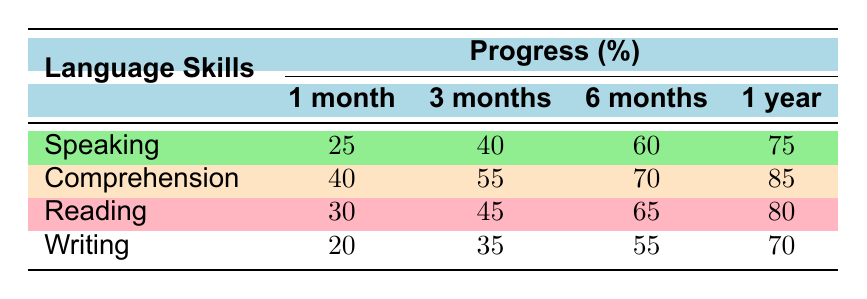What is the speaking skill percentage at 3 months post-stroke? The table shows that the progression of the speaking skill at the 3 months post-stroke mark is indicated directly under the "3 months" column for the "Speaking" row. The value is 40%.
Answer: 40% Which language skill had the highest percentage at 1 year post-stroke? The table lists the percentages for each skill at the 1 year post-stroke mark. The values are 75% for Speaking, 85% for Comprehension, 80% for Reading, and 70% for Writing. Comprehension is the highest at 85%.
Answer: Comprehension What is the average progress percentage for Reading over all time periods? To find the average for Reading, we add the percentages: \(30\% + 45\% + 65\% + 80\% = 220\%\). Then divide by 4 (number of time periods): \(220\% / 4 = 55\%\).
Answer: 55% Did the survivor achieve the milestone of writing a personal letter within the first 6 months post-stroke? The table shows the milestone of writing a personal letter was achieved at 7 months post-stroke. Since this is beyond 6 months, the answer is no.
Answer: No What is the difference in comprehension skill percentage between 1 month and 6 months post-stroke? The comprehension skill percentage at 1 month is 40% and at 6 months is 70%. The difference is calculated as \(70\% - 40\% = 30\%\).
Answer: 30% Which skill shows the least improvement from 1 month to 1 year post-stroke? To determine the least improvement, we calculate the progress for each skill from 1 month to 1 year: Speaking (75%-25% = 50%), Comprehension (85%-40% = 45%), Reading (80%-30% = 50%), and Writing (70%-20% = 50%). The lowest improvement is for Comprehension, with an improvement of 45%.
Answer: Comprehension What is the frequency of "Home Exercises with Sibling"? The "Home Exercises with Sibling" method has a listed frequency of "Daily" in the therapy methods section of the data.
Answer: Daily Calculate the total percentage improvement for speaking skill from 1 month to 1 year post-stroke. The speaking skill percentage at 1 month is 25% and at 1 year is 75%. The total improvement is \(75\% - 25\% = 50\%\).
Answer: 50% 